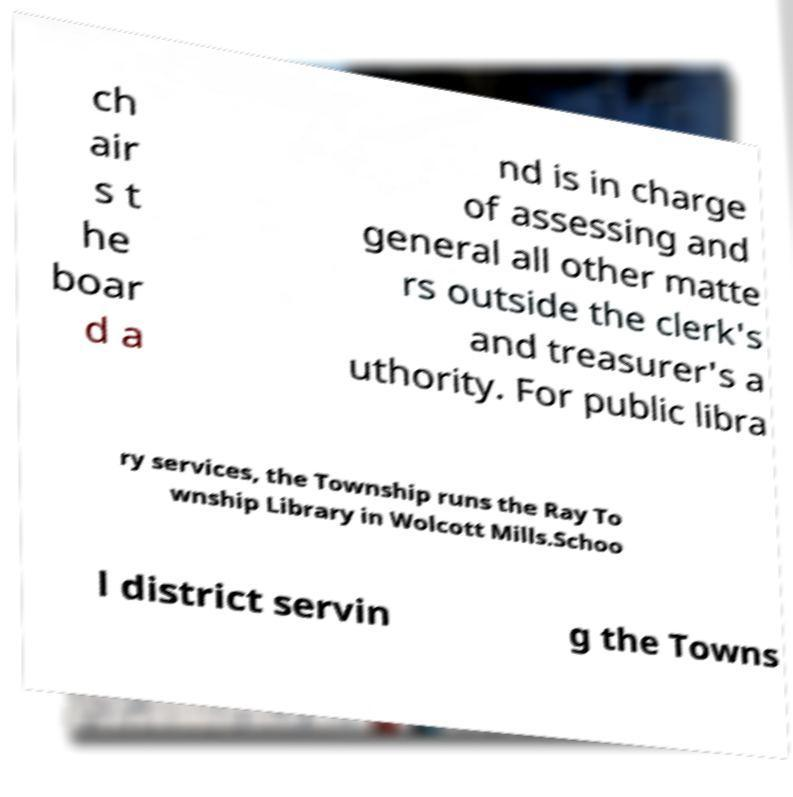Can you accurately transcribe the text from the provided image for me? ch air s t he boar d a nd is in charge of assessing and general all other matte rs outside the clerk's and treasurer's a uthority. For public libra ry services, the Township runs the Ray To wnship Library in Wolcott Mills.Schoo l district servin g the Towns 